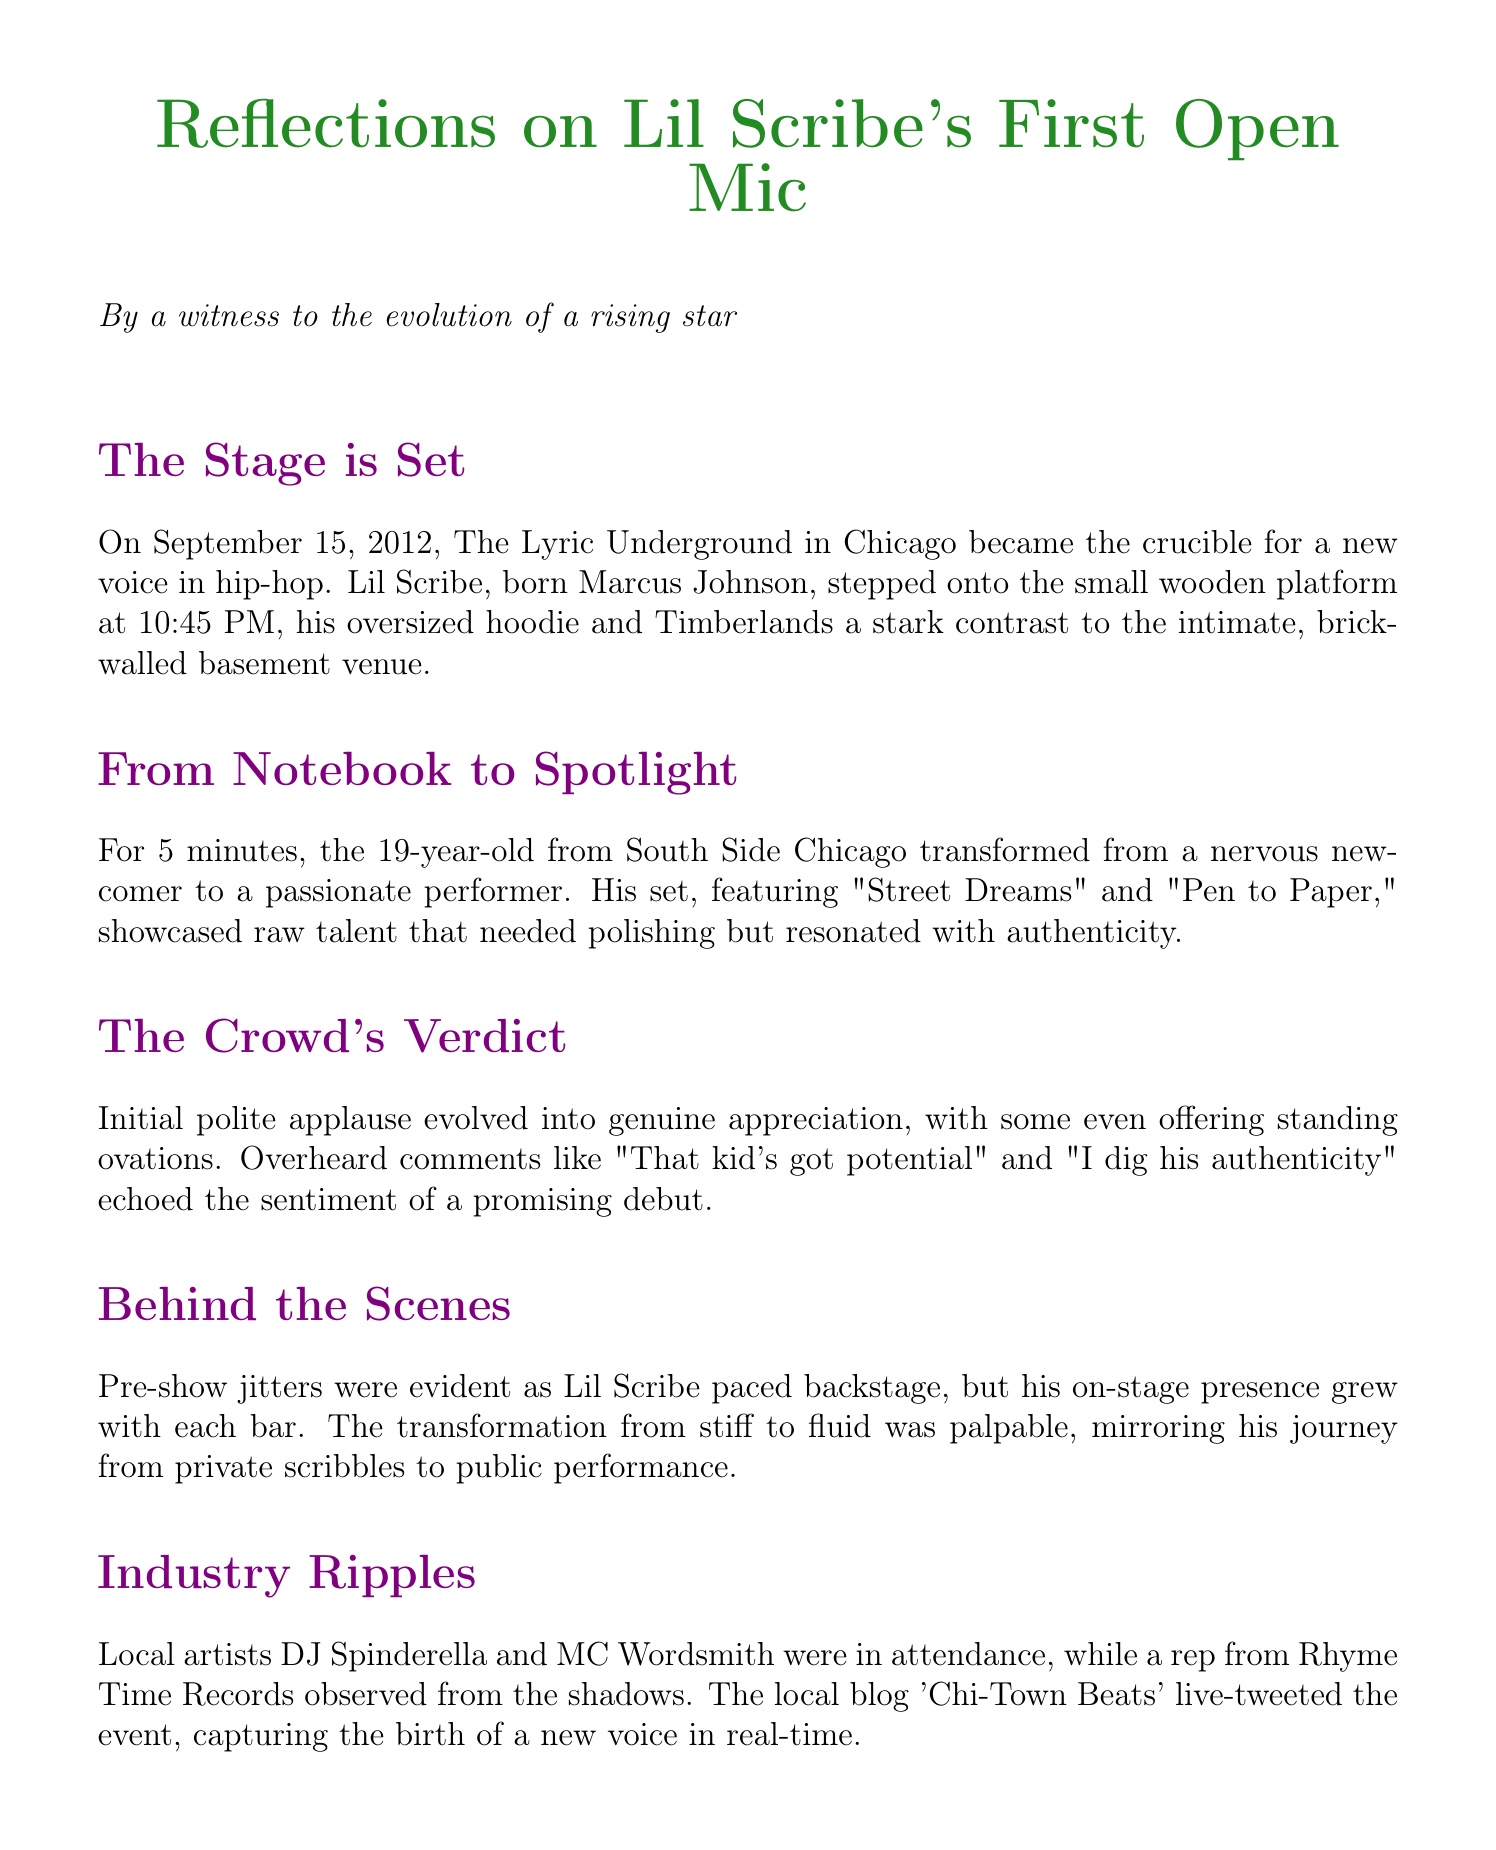What is the name of the venue? The document specifies that the performance took place at "The Lyric Underground."
Answer: The Lyric Underground What is the date of the performance? The performance occurred on "September 15, 2012," according to the performance details.
Answer: September 15, 2012 How long was the performance? The duration of the performance is noted as "5 minutes."
Answer: 5 minutes Who is the rapper's real name? The document identifies the rapper's real name as "Marcus Johnson."
Answer: Marcus Johnson What was the atmosphere of the venue described as? The atmosphere of the venue is described as "Dimly lit, intimate basement venue with exposed brick walls."
Answer: Dimly lit, intimate basement venue with exposed brick walls What was the crowd's initial response? The document mentions that the crowd's initial response was "Polite applause and curious murmurs."
Answer: Polite applause and curious murmurs Which local artists were in attendance? The document lists "DJ Spinderella" and "MC Wordsmith" as local artists present during the performance.
Answer: DJ Spinderella, MC Wordsmith What song features the notable lyrics mentioned? The notable lyrics provided come from the song "Pen to Paper," which is part of the performed set.
Answer: Pen to Paper What emotions did the rapper experience post-performance? The document describes the rapper's emotions after the performance as a mix of "relief, excitement, and newfound confidence."
Answer: Relief, excitement, and newfound confidence What feedback did the sound engineer give? The sound engineer's feedback was that he was "Impressed by the clarity of his vocals."
Answer: Impressed by the clarity of his vocals 